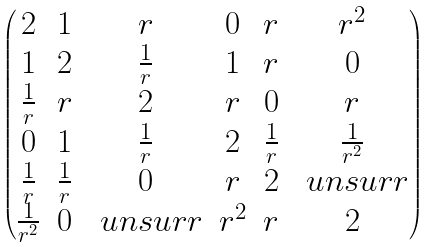<formula> <loc_0><loc_0><loc_500><loc_500>\begin{pmatrix} 2 & 1 & r & 0 & r & r ^ { 2 } \\ 1 & 2 & \frac { 1 } { r } & 1 & r & 0 \\ \frac { 1 } { r } & r & 2 & r & 0 & r \\ 0 & 1 & \frac { 1 } { r } & 2 & \frac { 1 } { r } & \frac { 1 } { r ^ { 2 } } \\ \frac { 1 } { r } & \frac { 1 } { r } & 0 & r & 2 & \ u n s u r r \\ \frac { 1 } { r ^ { 2 } } & 0 & \ u n s u r r & r ^ { 2 } & r & 2 \\ \end{pmatrix}</formula> 